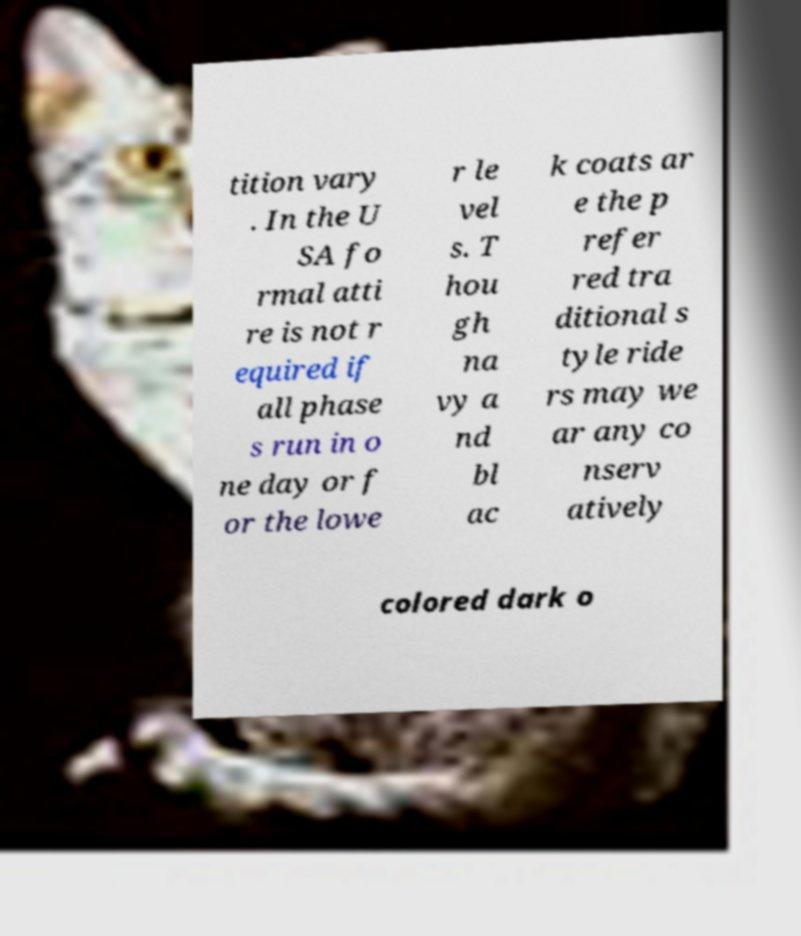Can you accurately transcribe the text from the provided image for me? tition vary . In the U SA fo rmal atti re is not r equired if all phase s run in o ne day or f or the lowe r le vel s. T hou gh na vy a nd bl ac k coats ar e the p refer red tra ditional s tyle ride rs may we ar any co nserv atively colored dark o 